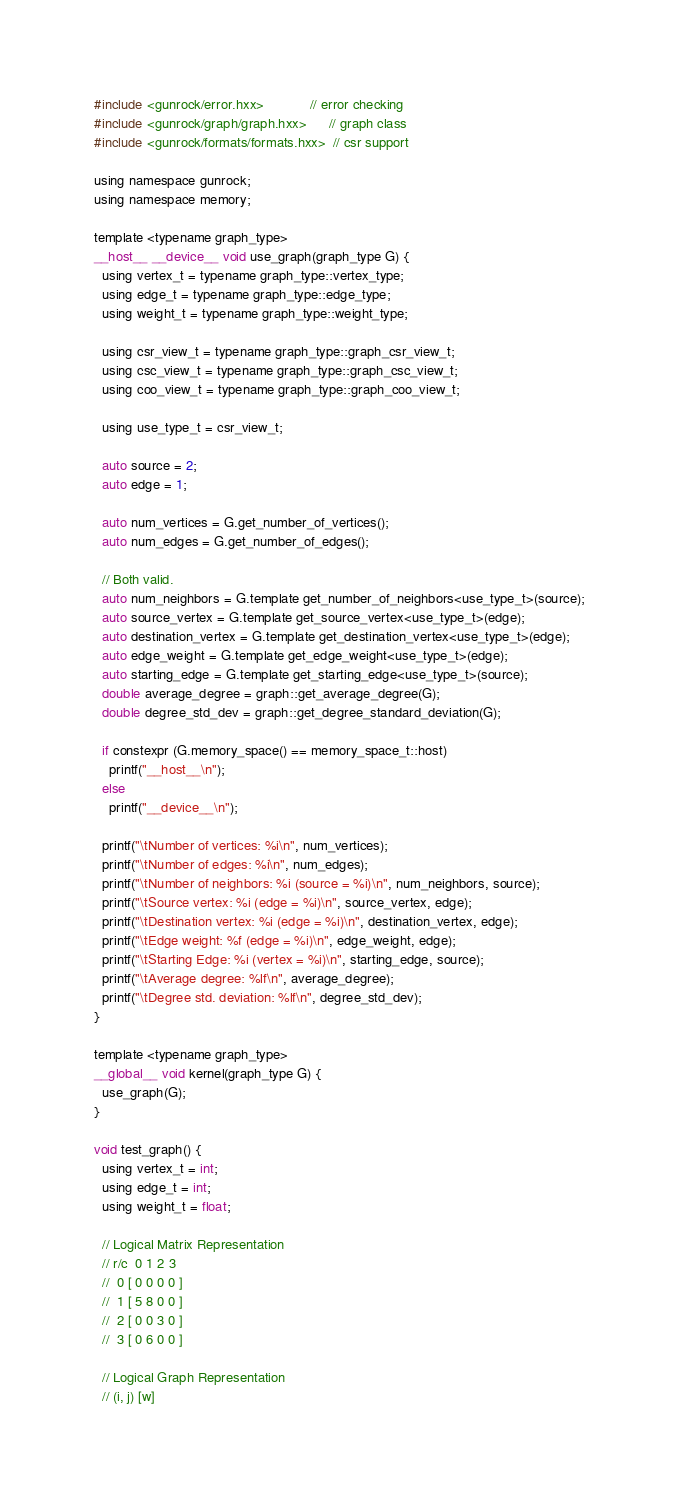<code> <loc_0><loc_0><loc_500><loc_500><_Cuda_>#include <gunrock/error.hxx>            // error checking
#include <gunrock/graph/graph.hxx>      // graph class
#include <gunrock/formats/formats.hxx>  // csr support

using namespace gunrock;
using namespace memory;

template <typename graph_type>
__host__ __device__ void use_graph(graph_type G) {
  using vertex_t = typename graph_type::vertex_type;
  using edge_t = typename graph_type::edge_type;
  using weight_t = typename graph_type::weight_type;

  using csr_view_t = typename graph_type::graph_csr_view_t;
  using csc_view_t = typename graph_type::graph_csc_view_t;
  using coo_view_t = typename graph_type::graph_coo_view_t;

  using use_type_t = csr_view_t;

  auto source = 2;
  auto edge = 1;

  auto num_vertices = G.get_number_of_vertices();
  auto num_edges = G.get_number_of_edges();

  // Both valid.
  auto num_neighbors = G.template get_number_of_neighbors<use_type_t>(source);
  auto source_vertex = G.template get_source_vertex<use_type_t>(edge);
  auto destination_vertex = G.template get_destination_vertex<use_type_t>(edge);
  auto edge_weight = G.template get_edge_weight<use_type_t>(edge);
  auto starting_edge = G.template get_starting_edge<use_type_t>(source);
  double average_degree = graph::get_average_degree(G);
  double degree_std_dev = graph::get_degree_standard_deviation(G);

  if constexpr (G.memory_space() == memory_space_t::host)
    printf("__host__\n");
  else
    printf("__device__\n");

  printf("\tNumber of vertices: %i\n", num_vertices);
  printf("\tNumber of edges: %i\n", num_edges);
  printf("\tNumber of neighbors: %i (source = %i)\n", num_neighbors, source);
  printf("\tSource vertex: %i (edge = %i)\n", source_vertex, edge);
  printf("\tDestination vertex: %i (edge = %i)\n", destination_vertex, edge);
  printf("\tEdge weight: %f (edge = %i)\n", edge_weight, edge);
  printf("\tStarting Edge: %i (vertex = %i)\n", starting_edge, source);
  printf("\tAverage degree: %lf\n", average_degree);
  printf("\tDegree std. deviation: %lf\n", degree_std_dev);
}

template <typename graph_type>
__global__ void kernel(graph_type G) {
  use_graph(G);
}

void test_graph() {
  using vertex_t = int;
  using edge_t = int;
  using weight_t = float;

  // Logical Matrix Representation
  // r/c  0 1 2 3
  //  0 [ 0 0 0 0 ]
  //  1 [ 5 8 0 0 ]
  //  2 [ 0 0 3 0 ]
  //  3 [ 0 6 0 0 ]

  // Logical Graph Representation
  // (i, j) [w]</code> 